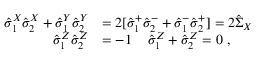<formula> <loc_0><loc_0><loc_500><loc_500>\begin{array} { r l } { \hat { \sigma } _ { 1 } ^ { X } \hat { \sigma } _ { 2 } ^ { X } + \hat { \sigma } _ { 1 } ^ { Y } \hat { \sigma } _ { 2 } ^ { Y } } & { = 2 [ \hat { \sigma } _ { 1 } ^ { + } \hat { \sigma } _ { 2 } ^ { - } + \hat { \sigma } _ { 1 } ^ { - } \hat { \sigma } _ { 2 } ^ { + } ] = 2 \hat { \Sigma } _ { X } } \\ { \hat { \sigma } _ { 1 } ^ { Z } \hat { \sigma } _ { 2 } ^ { Z } } & { = - 1 \, \quad \hat { \sigma } _ { 1 } ^ { Z } + \hat { \sigma } _ { 2 } ^ { Z } = 0 \ , } \end{array}</formula> 